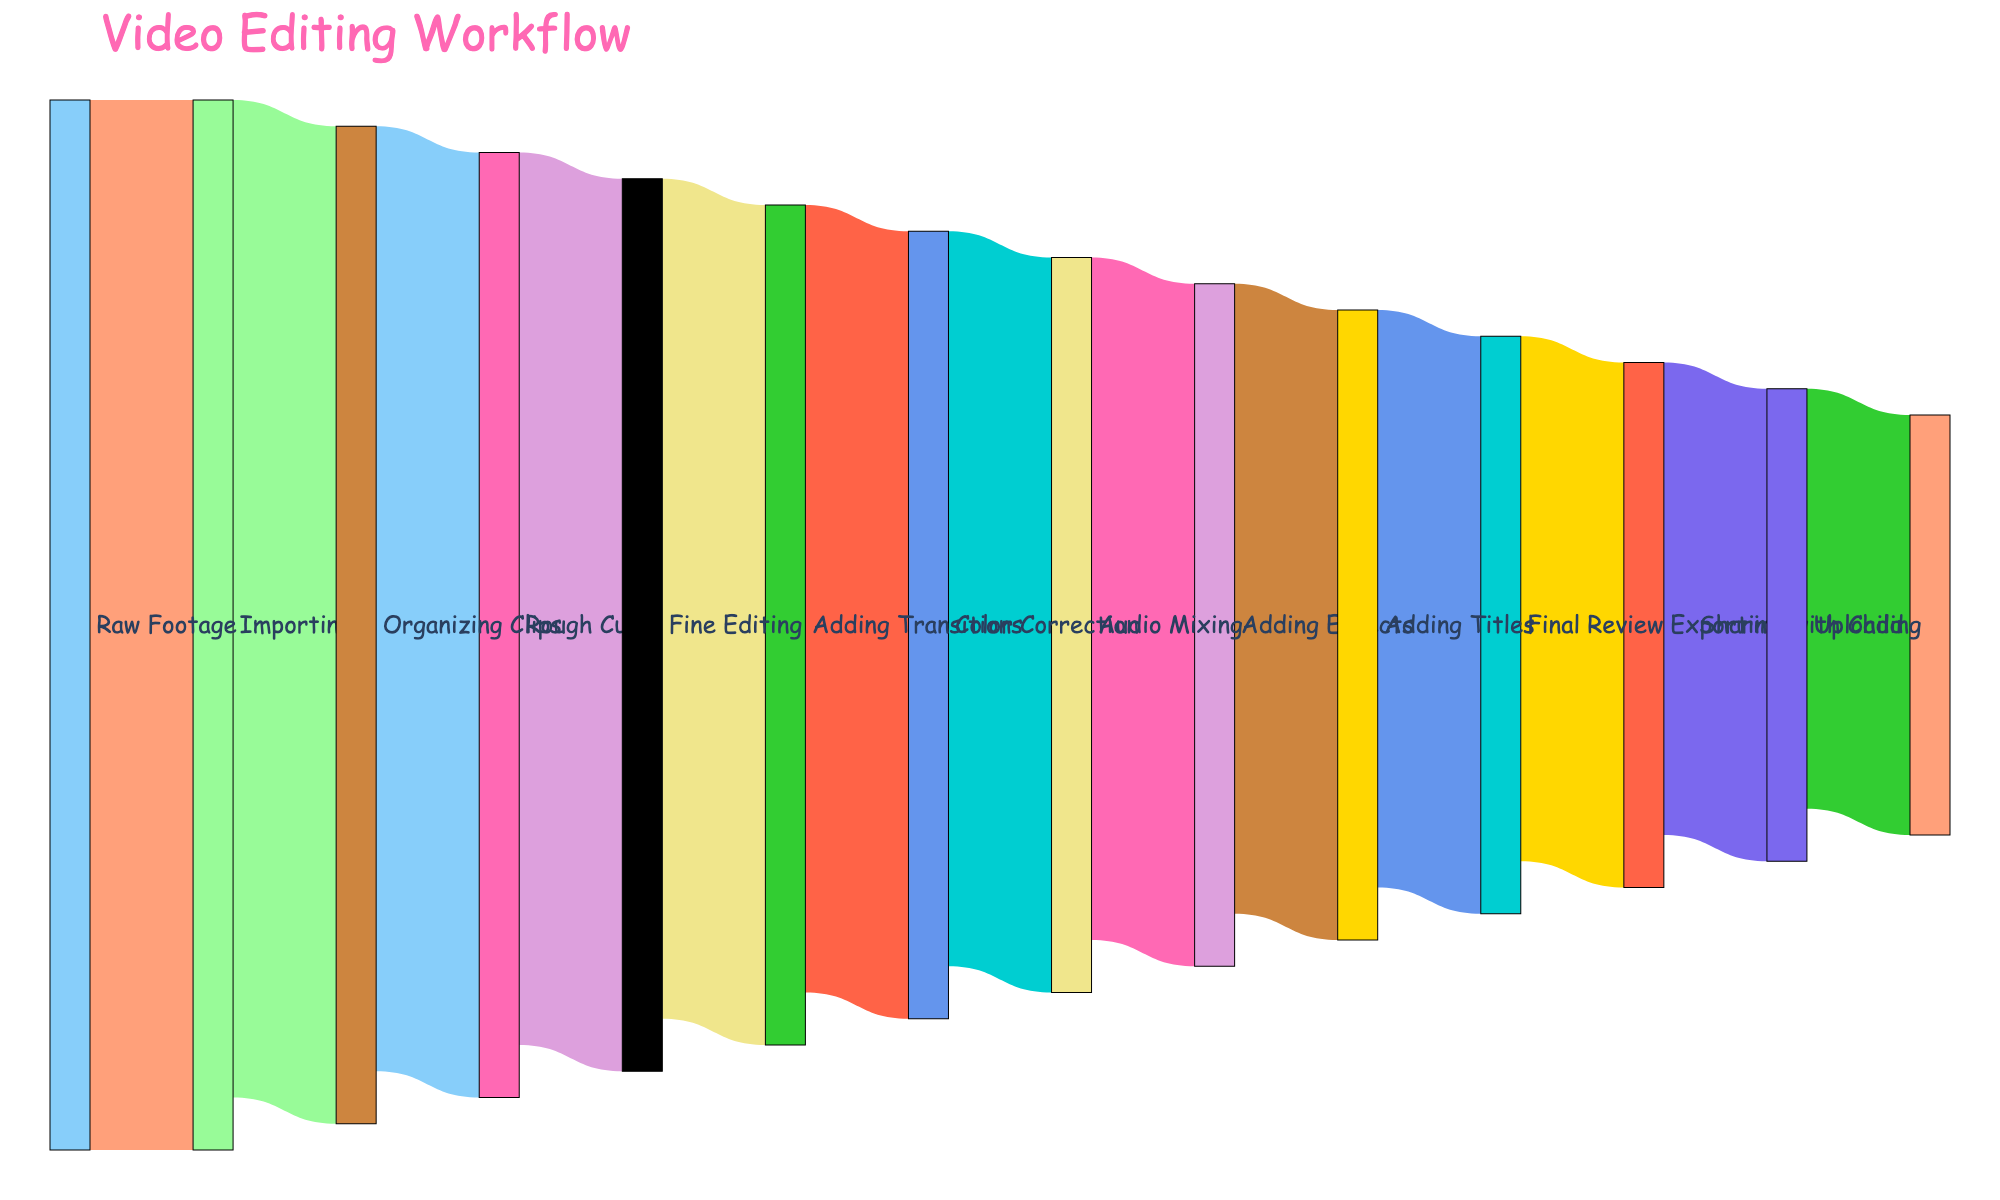What's the title of the figure? The title appears at the top of the figure in large, bold text. It's meant to summarize what the figure is about. The title here is "Video Editing Workflow."
Answer: Video Editing Workflow What are the first three stages in the video editing process? The stages are shown as nodes with labels in the figure. The flow starts from "Raw Footage," moves to "Importing," and then to "Organizing Clips."
Answer: Raw Footage, Importing, Organizing Clips How many units of footage are shared with the child at the end? By following the final link in the Sankey diagram, from "Uploading" to "Sharing with Child," you can see the value of this connection. The value is 40 units.
Answer: 40 Which stage directly follows "Rough Cut"? The nodes and connections display the sequential stages. "Fine Editing" directly follows "Rough Cut," as indicated by the arrow and flow between them.
Answer: Fine Editing How many stages are involved in the video editing workflow? The distinct stages can be counted from the unique labels in the figure. There are 13 unique stages listed.
Answer: 13 How many units move from "Color Correction" to "Audio Mixing"? Locate the link between "Color Correction" and "Audio Mixing." The value labeled on this connection shows 70 units.
Answer: 70 What is the difference in units between the "Raw Footage" and "Final Review" stages? The values are 100 for "Raw Footage" and 55 for "Final Review." Subtract these values to find the difference (100 - 55).
Answer: 45 Which stage has the smallest contribution in terms of units? By examining the values associated with each stage, it is visible that "Sharing with Child" has the smallest value, 40.
Answer: Sharing with Child How many units are lost from "Fine Editing" to "Adding Transitions"? The units decrease from 85 in "Fine Editing" to 80 in "Adding Transitions." The drop can be calculated as 85 - 80.
Answer: 5 What is the total value of units from "Adding Titles" to "Exporting"? Summing the values from "Adding Titles" (60) and "Final Review" (55), and finally "Exporting" (50), you get 165, but note the actual output is 50 units moving from "Final Review" to "Exporting."
Answer: 50 